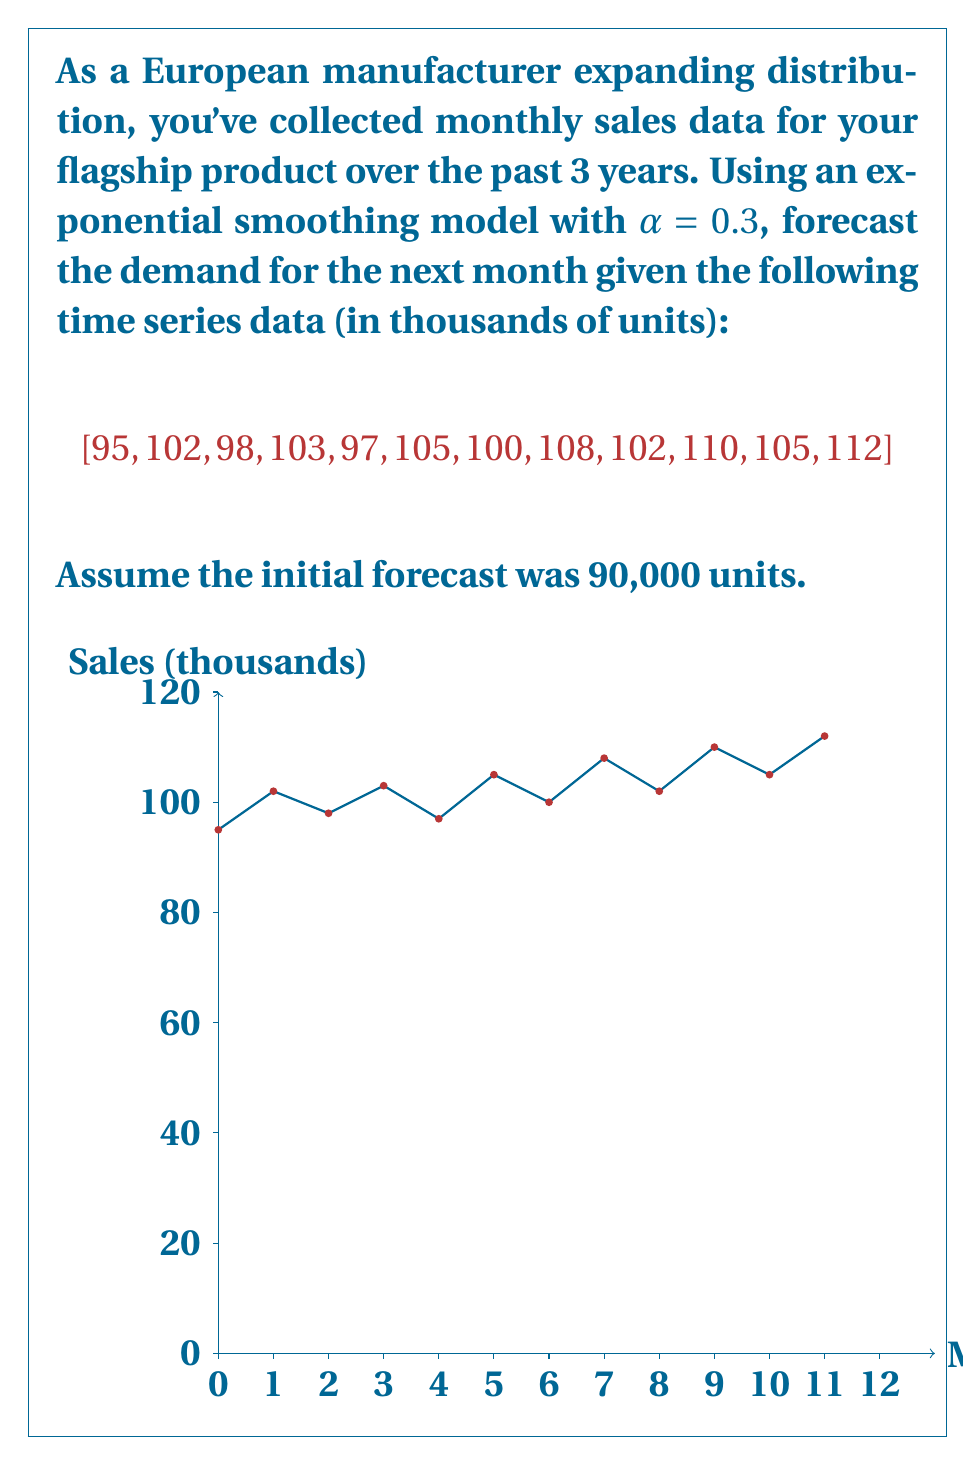Could you help me with this problem? To forecast demand using exponential smoothing, we use the formula:

$$F_{t+1} = \alpha Y_t + (1-\alpha)F_t$$

Where:
$F_{t+1}$ is the forecast for the next period
$\alpha$ is the smoothing constant (0.3 in this case)
$Y_t$ is the actual observation in the current period
$F_t$ is the forecast for the current period

Let's calculate step-by-step:

1) Initial forecast $F_1 = 90$

2) For month 1:
   $F_2 = 0.3(95) + 0.7(90) = 28.5 + 63 = 91.5$

3) For month 2:
   $F_3 = 0.3(102) + 0.7(91.5) = 30.6 + 64.05 = 94.65$

4) Continue this process for all 12 months:
   Month 3: $F_4 = 0.3(98) + 0.7(94.65) = 95.655$
   ...
   Month 12: $F_{13} = 0.3(112) + 0.7(107.0822) = 108.5575$

The forecast for the next month (13th month) is 108.5575 thousand units.
Answer: 108,558 units 